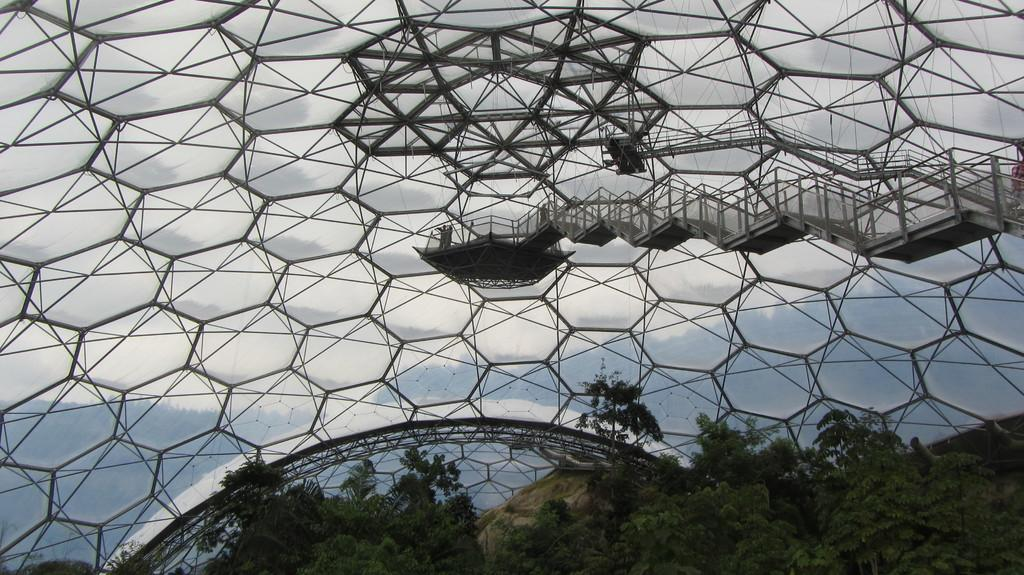What type of vegetation can be seen in the image? There are trees in the image. What type of roof is visible in the image? There is a glass roof in the image. Can you describe the design of the glass roof? The glass roof has hexagonal designs. What direction is the station located in the image? There is no station present in the image. How much dirt is visible on the trees in the image? There is no dirt visible on the trees in the image; they appear to be clean and healthy. 